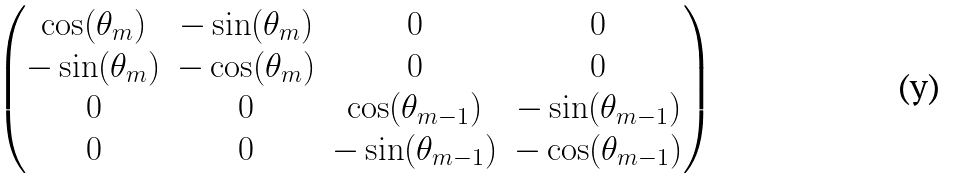<formula> <loc_0><loc_0><loc_500><loc_500>\begin{pmatrix} \cos ( \theta _ { m } ) & - \sin ( \theta _ { m } ) & 0 & 0 \\ - \sin ( \theta _ { m } ) & - \cos ( \theta _ { m } ) & 0 & 0 \\ 0 & 0 & \cos ( \theta _ { m - 1 } ) & - \sin ( \theta _ { m - 1 } ) \\ 0 & 0 & - \sin ( \theta _ { m - 1 } ) & - \cos ( \theta _ { m - 1 } ) \end{pmatrix}</formula> 